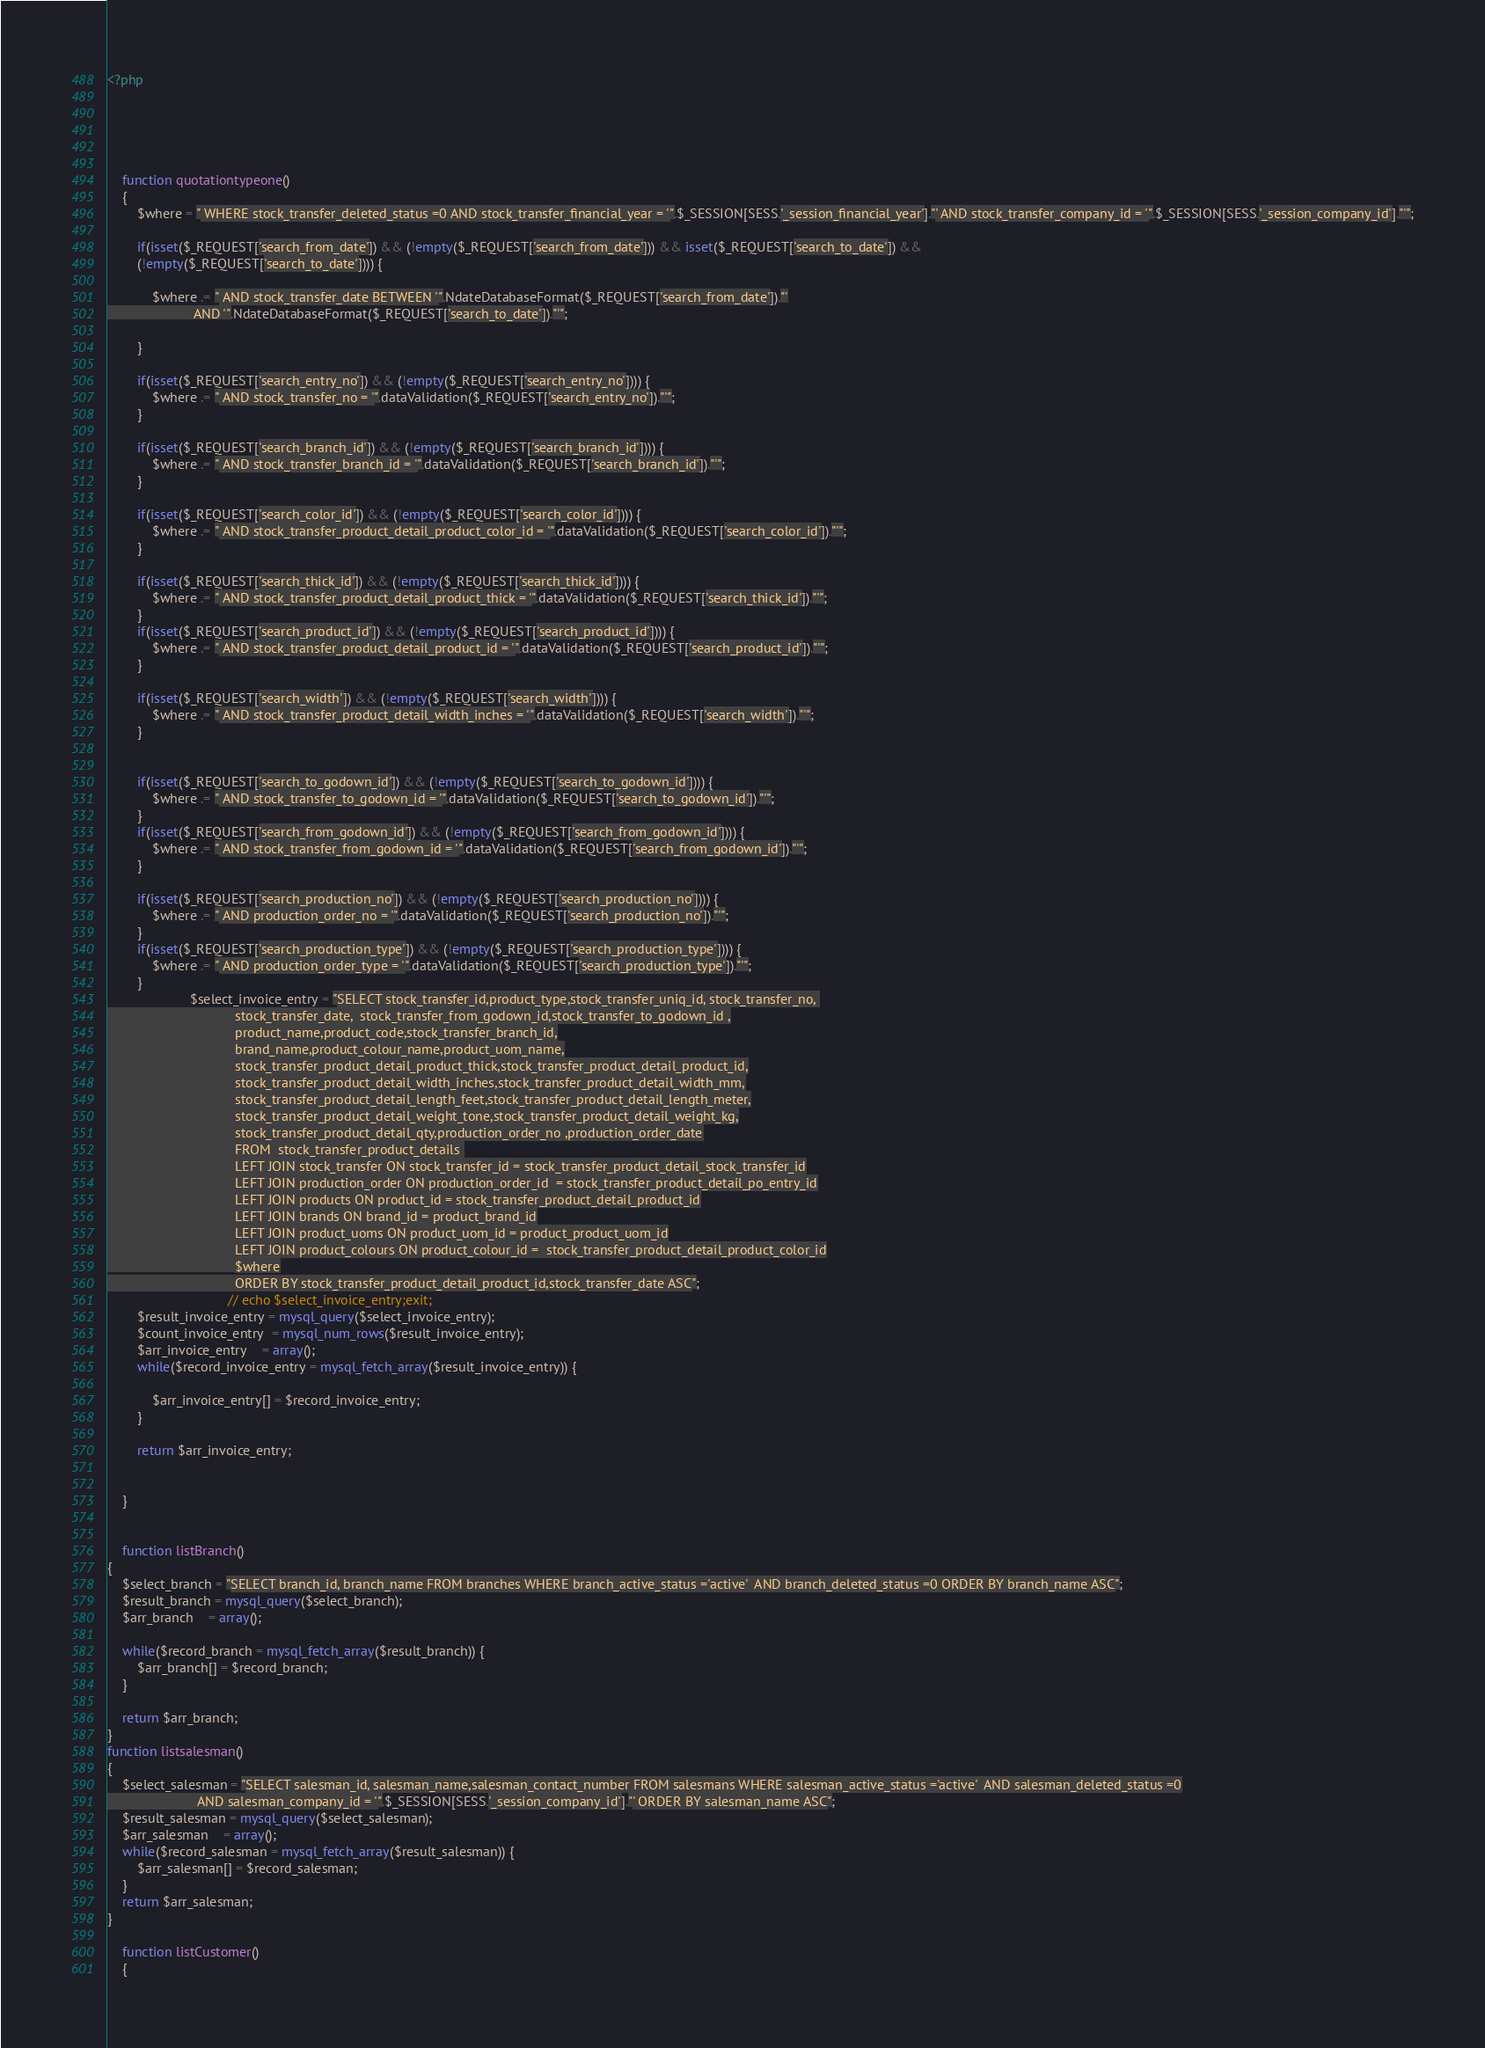Convert code to text. <code><loc_0><loc_0><loc_500><loc_500><_PHP_><?php  

	
	
	

	function quotationtypeone()
	{
		$where = " WHERE stock_transfer_deleted_status =0 AND stock_transfer_financial_year = '".$_SESSION[SESS.'_session_financial_year']."' AND stock_transfer_company_id = '".$_SESSION[SESS.'_session_company_id']."'";
		
		if(isset($_REQUEST['search_from_date']) && (!empty($_REQUEST['search_from_date'])) && isset($_REQUEST['search_to_date']) && 
		(!empty($_REQUEST['search_to_date']))) {
		
			$where .= " AND stock_transfer_date BETWEEN '".NdateDatabaseFormat($_REQUEST['search_from_date'])."'
					   AND '".NdateDatabaseFormat($_REQUEST['search_to_date'])."'";	
			
		}
		
		if(isset($_REQUEST['search_entry_no']) && (!empty($_REQUEST['search_entry_no']))) {
			$where .= " AND stock_transfer_no = '".dataValidation($_REQUEST['search_entry_no'])."'";
		}
		
		if(isset($_REQUEST['search_branch_id']) && (!empty($_REQUEST['search_branch_id']))) {
			$where .= " AND stock_transfer_branch_id = '".dataValidation($_REQUEST['search_branch_id'])."'";
		}
		
		if(isset($_REQUEST['search_color_id']) && (!empty($_REQUEST['search_color_id']))) {
			$where .= " AND stock_transfer_product_detail_product_color_id = '".dataValidation($_REQUEST['search_color_id'])."'";
		}
		
		if(isset($_REQUEST['search_thick_id']) && (!empty($_REQUEST['search_thick_id']))) {
			$where .= " AND stock_transfer_product_detail_product_thick = '".dataValidation($_REQUEST['search_thick_id'])."'";
		}
		if(isset($_REQUEST['search_product_id']) && (!empty($_REQUEST['search_product_id']))) {
			$where .= " AND stock_transfer_product_detail_product_id = '".dataValidation($_REQUEST['search_product_id'])."'";
		}
		
		if(isset($_REQUEST['search_width']) && (!empty($_REQUEST['search_width']))) {
			$where .= " AND stock_transfer_product_detail_width_inches = '".dataValidation($_REQUEST['search_width'])."'";
		}
		
		
		if(isset($_REQUEST['search_to_godown_id']) && (!empty($_REQUEST['search_to_godown_id']))) {
			$where .= " AND stock_transfer_to_godown_id = '".dataValidation($_REQUEST['search_to_godown_id'])."'";
		}
		if(isset($_REQUEST['search_from_godown_id']) && (!empty($_REQUEST['search_from_godown_id']))) {
			$where .= " AND stock_transfer_from_godown_id = '".dataValidation($_REQUEST['search_from_godown_id'])."'";
		}
		
		if(isset($_REQUEST['search_production_no']) && (!empty($_REQUEST['search_production_no']))) {
			$where .= " AND production_order_no = '".dataValidation($_REQUEST['search_production_no'])."'";
		}
		if(isset($_REQUEST['search_production_type']) && (!empty($_REQUEST['search_production_type']))) {
			$where .= " AND production_order_type = '".dataValidation($_REQUEST['search_production_type'])."'";
		}
		              $select_invoice_entry = "SELECT stock_transfer_id,product_type,stock_transfer_uniq_id, stock_transfer_no, 
								  stock_transfer_date,	stock_transfer_from_godown_id,stock_transfer_to_godown_id ,
								  product_name,product_code,stock_transfer_branch_id,
								  brand_name,product_colour_name,product_uom_name,
								  stock_transfer_product_detail_product_thick,stock_transfer_product_detail_product_id,
								  stock_transfer_product_detail_width_inches,stock_transfer_product_detail_width_mm,
								  stock_transfer_product_detail_length_feet,stock_transfer_product_detail_length_meter,
								  stock_transfer_product_detail_weight_tone,stock_transfer_product_detail_weight_kg,
								  stock_transfer_product_detail_qty,production_order_no	,production_order_date
								  FROM  stock_transfer_product_details 
								  LEFT JOIN stock_transfer ON stock_transfer_id = stock_transfer_product_detail_stock_transfer_id
								  LEFT JOIN production_order ON production_order_id	 = stock_transfer_product_detail_po_entry_id
								  LEFT JOIN products ON product_id = stock_transfer_product_detail_product_id
								  LEFT JOIN brands ON brand_id = product_brand_id
								  LEFT JOIN product_uoms ON product_uom_id = product_product_uom_id
								  LEFT JOIN product_colours ON product_colour_id =  stock_transfer_product_detail_product_color_id
								  $where
								  ORDER BY stock_transfer_product_detail_product_id,stock_transfer_date ASC";
								// echo $select_invoice_entry;exit; 
		$result_invoice_entry = mysql_query($select_invoice_entry);
		$count_invoice_entry  = mysql_num_rows($result_invoice_entry);
		$arr_invoice_entry    = array();
		while($record_invoice_entry = mysql_fetch_array($result_invoice_entry)) {
			
			$arr_invoice_entry[] = $record_invoice_entry;
		}
		
		return $arr_invoice_entry;
			
		
	}
	
	
	function listBranch()
{
	$select_branch = "SELECT branch_id, branch_name FROM branches WHERE branch_active_status ='active'  AND branch_deleted_status =0 ORDER BY branch_name ASC";
	$result_branch = mysql_query($select_branch);
	$arr_branch    = array();
	
	while($record_branch = mysql_fetch_array($result_branch)) {
		$arr_branch[] = $record_branch;
	}
	
	return $arr_branch;
}
function listsalesman()
{
	$select_salesman = "SELECT salesman_id, salesman_name,salesman_contact_number FROM salesmans WHERE salesman_active_status ='active'  AND salesman_deleted_status =0
						AND salesman_company_id = '".$_SESSION[SESS.'_session_company_id']."' ORDER BY salesman_name ASC";
	$result_salesman = mysql_query($select_salesman);
	$arr_salesman    = array();
	while($record_salesman = mysql_fetch_array($result_salesman)) {
		$arr_salesman[] = $record_salesman;
	}
	return $arr_salesman;
}

	function listCustomer()
	{</code> 